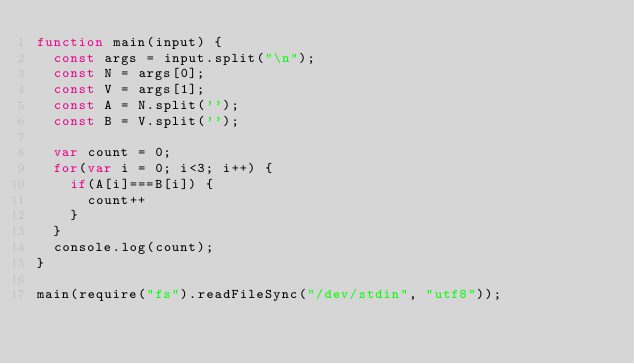Convert code to text. <code><loc_0><loc_0><loc_500><loc_500><_JavaScript_>function main(input) {
  const args = input.split("\n");
  const N = args[0];
  const V = args[1];
  const A = N.split('');
  const B = V.split('');
  
  var count = 0;
  for(var i = 0; i<3; i++) {
    if(A[i]===B[i]) {
      count++
    }
  }
  console.log(count);
}

main(require("fs").readFileSync("/dev/stdin", "utf8"));
</code> 